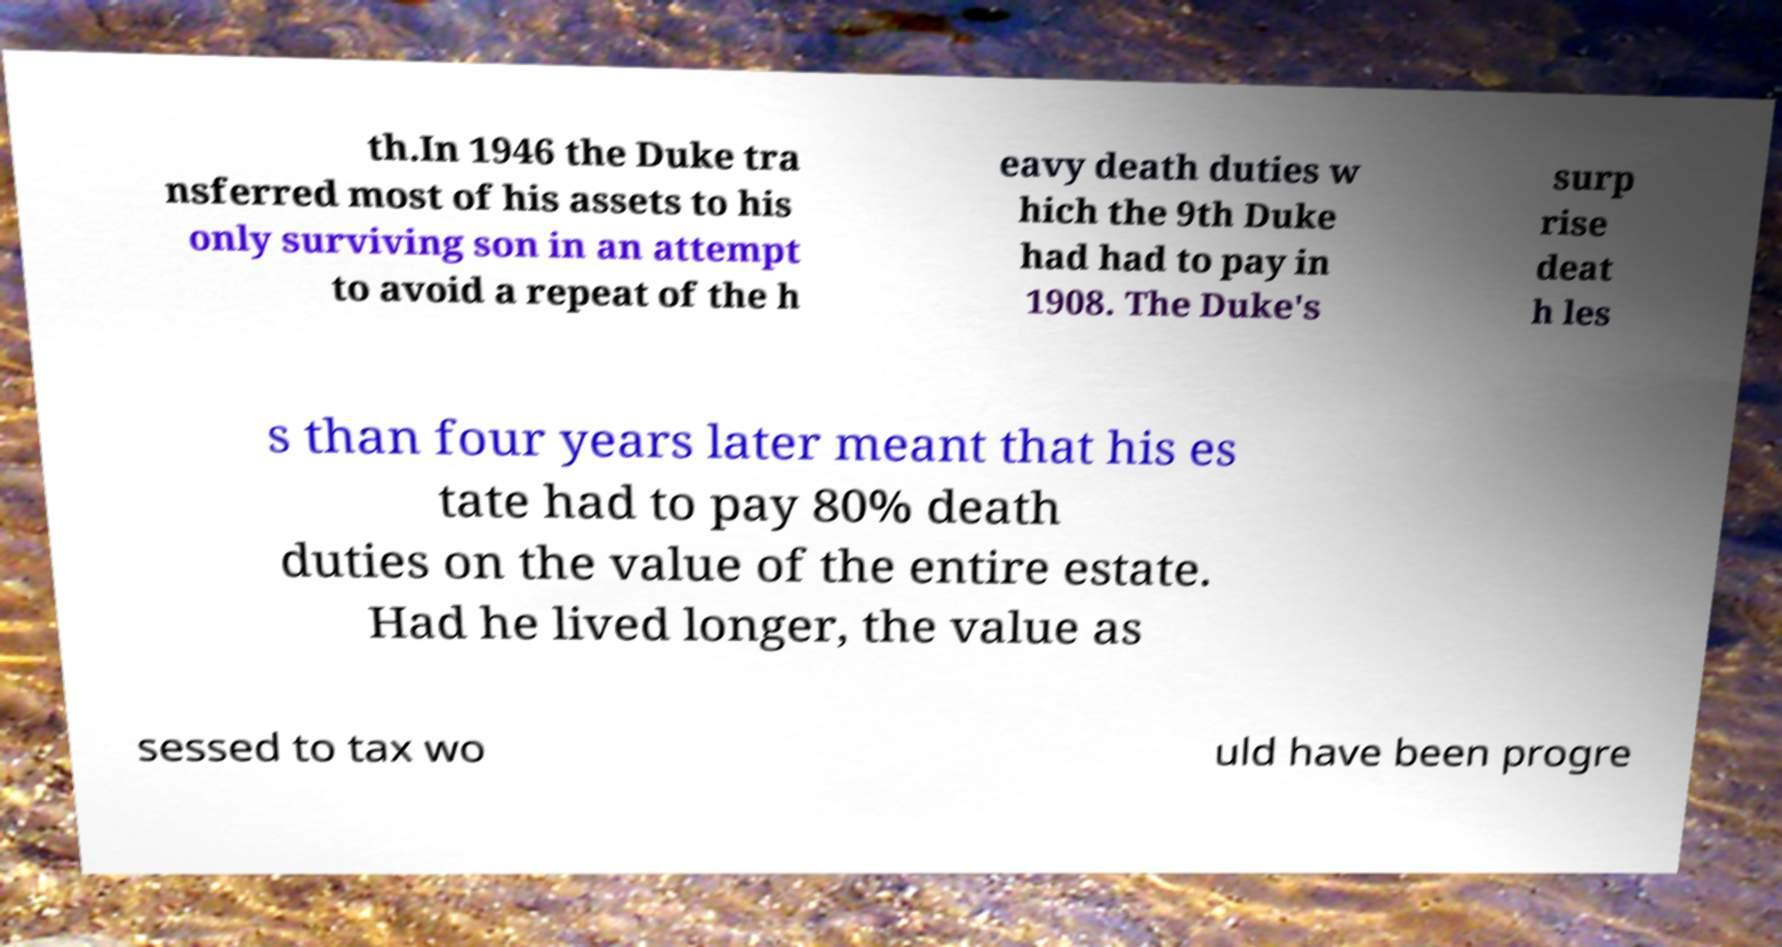Please read and relay the text visible in this image. What does it say? th.In 1946 the Duke tra nsferred most of his assets to his only surviving son in an attempt to avoid a repeat of the h eavy death duties w hich the 9th Duke had had to pay in 1908. The Duke's surp rise deat h les s than four years later meant that his es tate had to pay 80% death duties on the value of the entire estate. Had he lived longer, the value as sessed to tax wo uld have been progre 